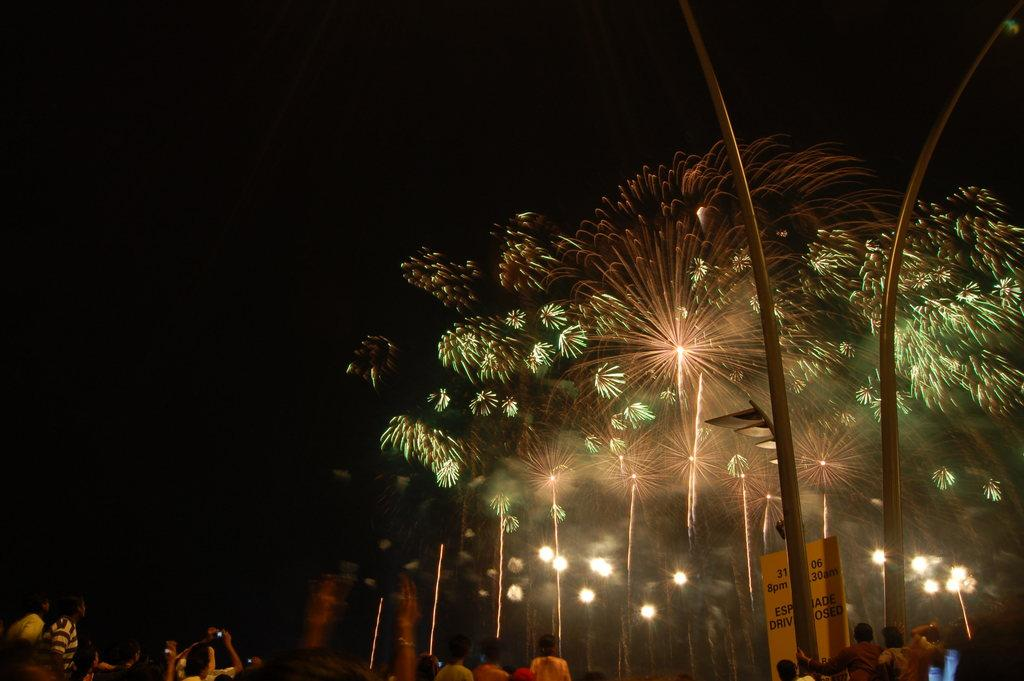What are the people in the image doing? The people in the image are standing on the road. What can be seen on the right side of the image? There is a board on the right side of the image. What is visible in the background of the image? There are lights visible in the background of the image. Where is the playground located in the image? There is no playground present in the image. Can you tell me who made the request for the people to stand on the road? There is no information about a request or any specific person making it in the image. 